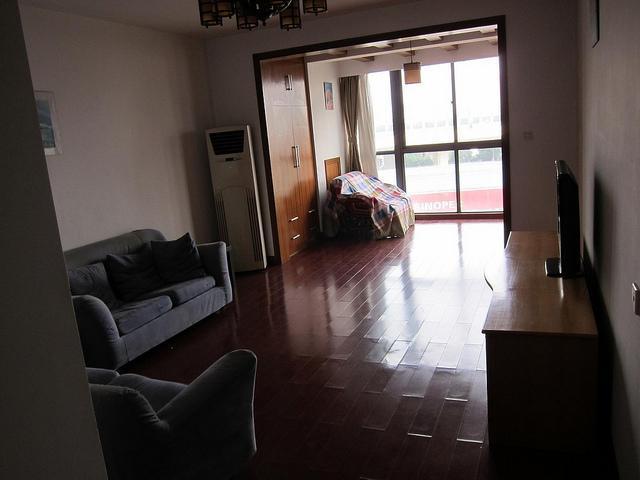How many TVs are visible?
Give a very brief answer. 1. How many couches are in the photo?
Give a very brief answer. 2. 